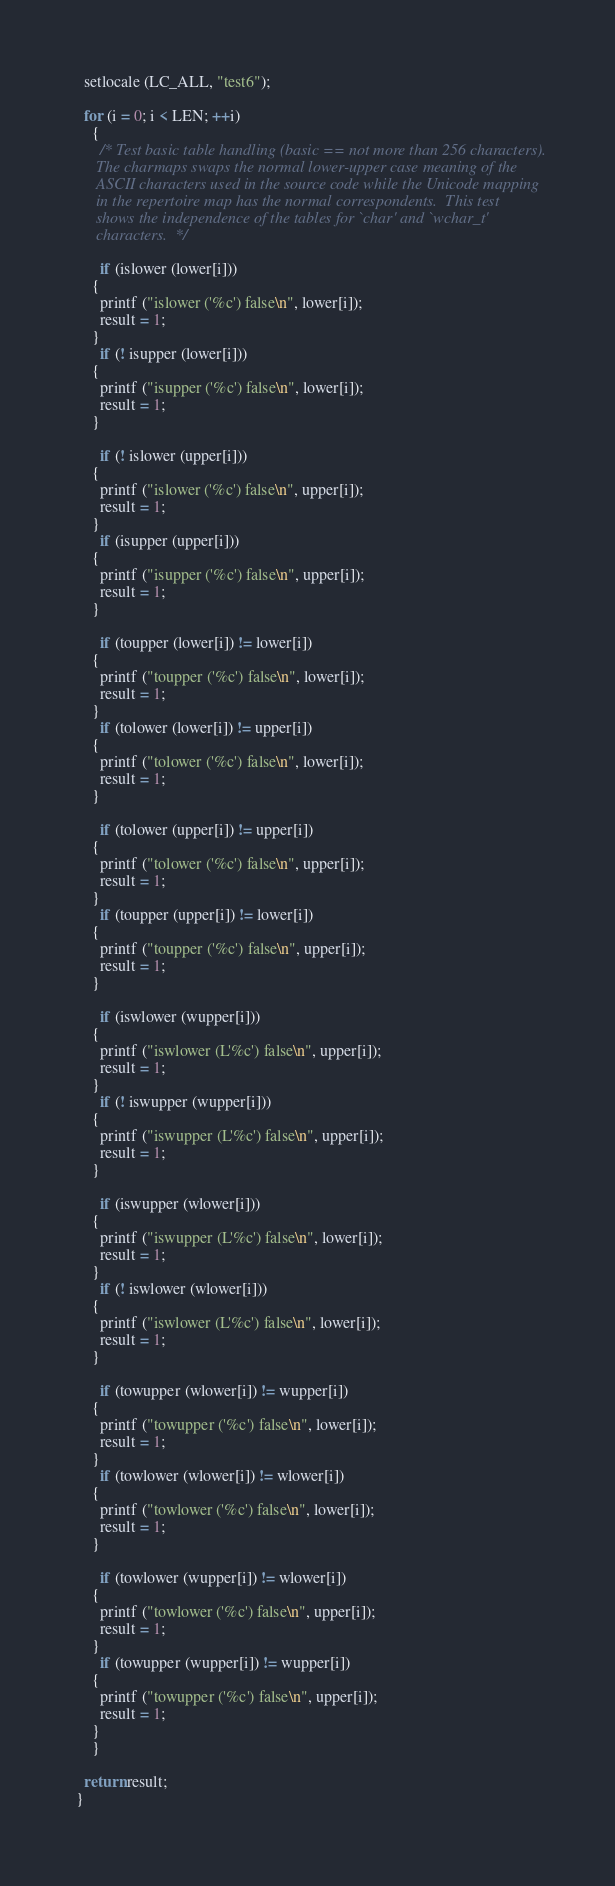<code> <loc_0><loc_0><loc_500><loc_500><_C_>
  setlocale (LC_ALL, "test6");

  for (i = 0; i < LEN; ++i)
    {
      /* Test basic table handling (basic == not more than 256 characters).
	 The charmaps swaps the normal lower-upper case meaning of the
	 ASCII characters used in the source code while the Unicode mapping
	 in the repertoire map has the normal correspondents.  This test
	 shows the independence of the tables for `char' and `wchar_t'
	 characters.  */

      if (islower (lower[i]))
	{
	  printf ("islower ('%c') false\n", lower[i]);
	  result = 1;
	}
      if (! isupper (lower[i]))
	{
	  printf ("isupper ('%c') false\n", lower[i]);
	  result = 1;
	}

      if (! islower (upper[i]))
	{
	  printf ("islower ('%c') false\n", upper[i]);
	  result = 1;
	}
      if (isupper (upper[i]))
	{
	  printf ("isupper ('%c') false\n", upper[i]);
	  result = 1;
	}

      if (toupper (lower[i]) != lower[i])
	{
	  printf ("toupper ('%c') false\n", lower[i]);
	  result = 1;
	}
      if (tolower (lower[i]) != upper[i])
	{
	  printf ("tolower ('%c') false\n", lower[i]);
	  result = 1;
	}

      if (tolower (upper[i]) != upper[i])
	{
	  printf ("tolower ('%c') false\n", upper[i]);
	  result = 1;
	}
      if (toupper (upper[i]) != lower[i])
	{
	  printf ("toupper ('%c') false\n", upper[i]);
	  result = 1;
	}

      if (iswlower (wupper[i]))
	{
	  printf ("iswlower (L'%c') false\n", upper[i]);
	  result = 1;
	}
      if (! iswupper (wupper[i]))
	{
	  printf ("iswupper (L'%c') false\n", upper[i]);
	  result = 1;
	}

      if (iswupper (wlower[i]))
	{
	  printf ("iswupper (L'%c') false\n", lower[i]);
	  result = 1;
	}
      if (! iswlower (wlower[i]))
	{
	  printf ("iswlower (L'%c') false\n", lower[i]);
	  result = 1;
	}

      if (towupper (wlower[i]) != wupper[i])
	{
	  printf ("towupper ('%c') false\n", lower[i]);
	  result = 1;
	}
      if (towlower (wlower[i]) != wlower[i])
	{
	  printf ("towlower ('%c') false\n", lower[i]);
	  result = 1;
	}

      if (towlower (wupper[i]) != wlower[i])
	{
	  printf ("towlower ('%c') false\n", upper[i]);
	  result = 1;
	}
      if (towupper (wupper[i]) != wupper[i])
	{
	  printf ("towupper ('%c') false\n", upper[i]);
	  result = 1;
	}
    }

  return result;
}
</code> 